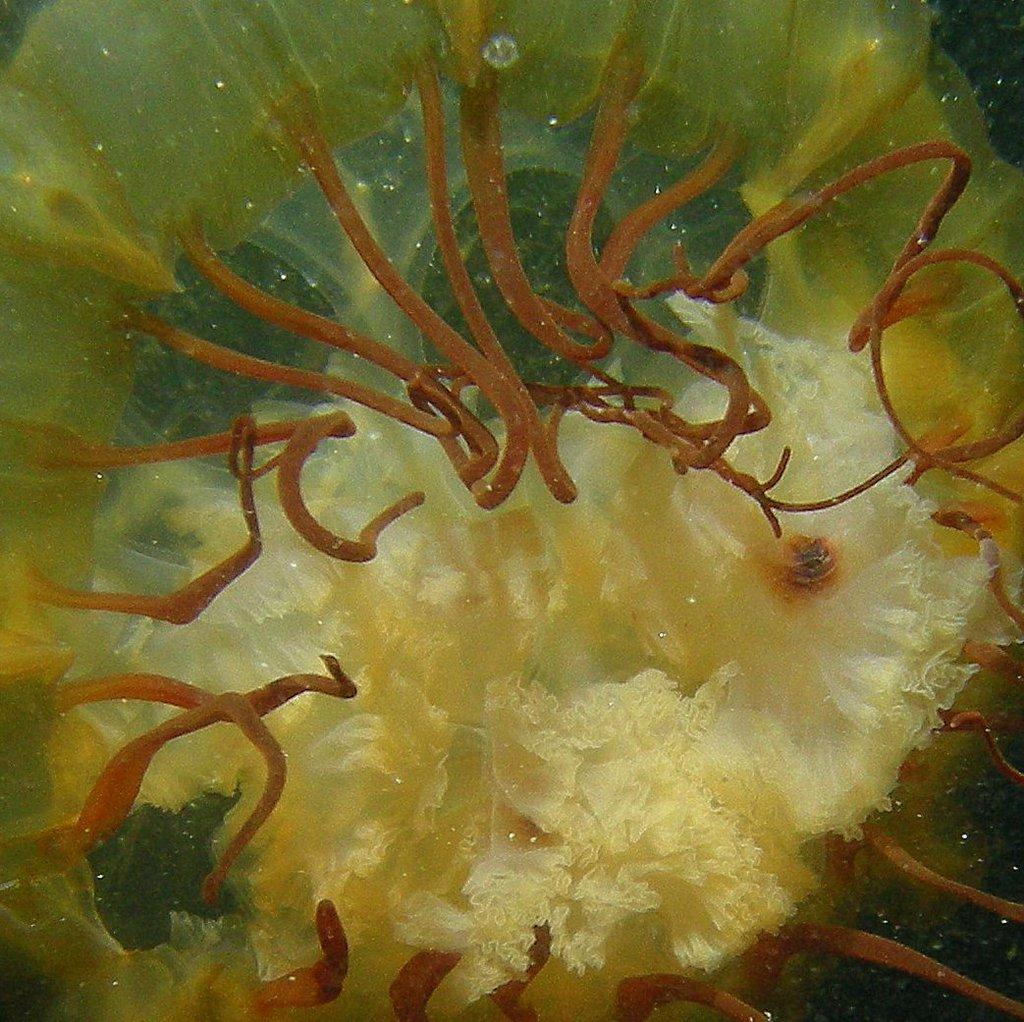What type of artwork is depicted in the image? The image is a painting. What type of whip is being used by the person in the harbor in the image? There is no person or harbor present in the image, and therefore no whip can be observed. 